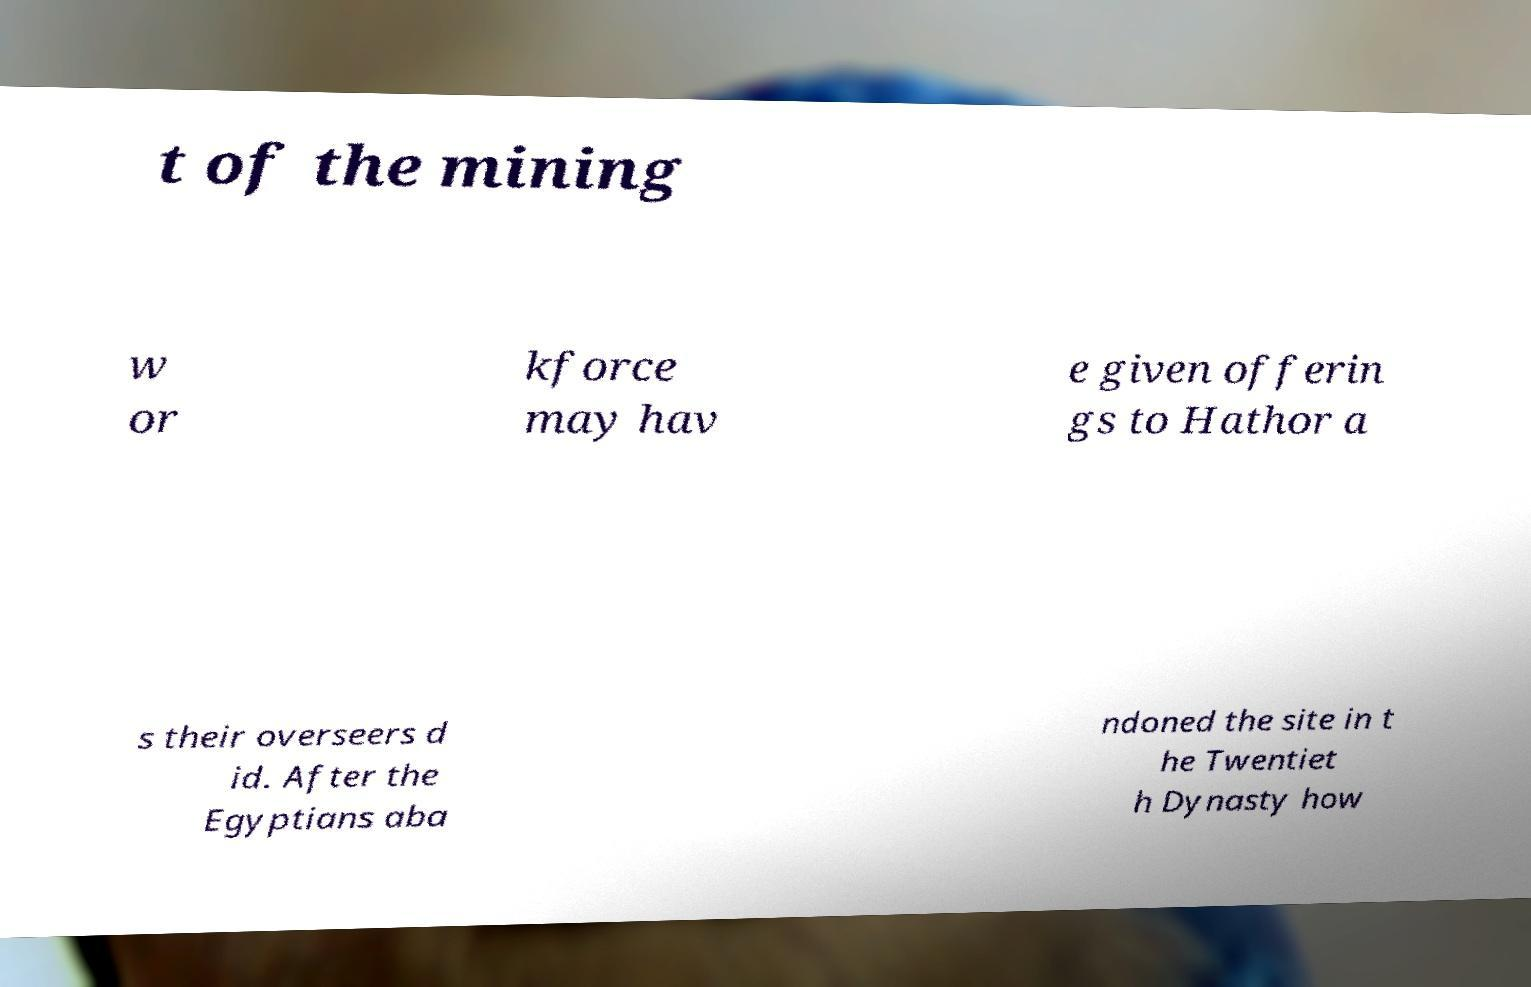Can you read and provide the text displayed in the image?This photo seems to have some interesting text. Can you extract and type it out for me? t of the mining w or kforce may hav e given offerin gs to Hathor a s their overseers d id. After the Egyptians aba ndoned the site in t he Twentiet h Dynasty how 